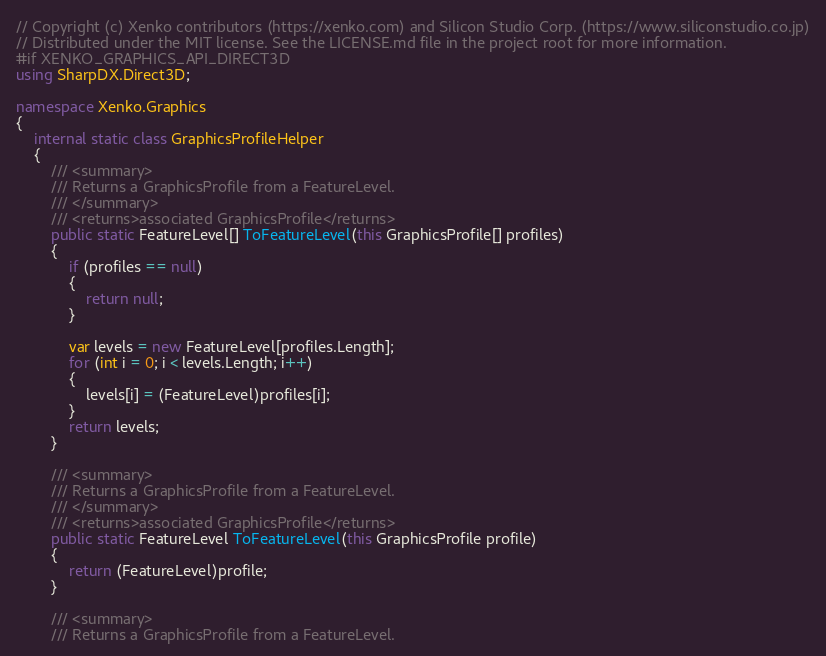<code> <loc_0><loc_0><loc_500><loc_500><_C#_>// Copyright (c) Xenko contributors (https://xenko.com) and Silicon Studio Corp. (https://www.siliconstudio.co.jp)
// Distributed under the MIT license. See the LICENSE.md file in the project root for more information.
#if XENKO_GRAPHICS_API_DIRECT3D 
using SharpDX.Direct3D;

namespace Xenko.Graphics
{
    internal static class GraphicsProfileHelper
    {
        /// <summary>
        /// Returns a GraphicsProfile from a FeatureLevel.
        /// </summary>
        /// <returns>associated GraphicsProfile</returns>
        public static FeatureLevel[] ToFeatureLevel(this GraphicsProfile[] profiles)
        {
            if (profiles == null)
            {
                return null;
            }

            var levels = new FeatureLevel[profiles.Length];
            for (int i = 0; i < levels.Length; i++)
            {
                levels[i] = (FeatureLevel)profiles[i];
            }
            return levels;
        }
        
        /// <summary>
        /// Returns a GraphicsProfile from a FeatureLevel.
        /// </summary>
        /// <returns>associated GraphicsProfile</returns>
        public static FeatureLevel ToFeatureLevel(this GraphicsProfile profile)
        {
            return (FeatureLevel)profile;
        }

        /// <summary>
        /// Returns a GraphicsProfile from a FeatureLevel.</code> 